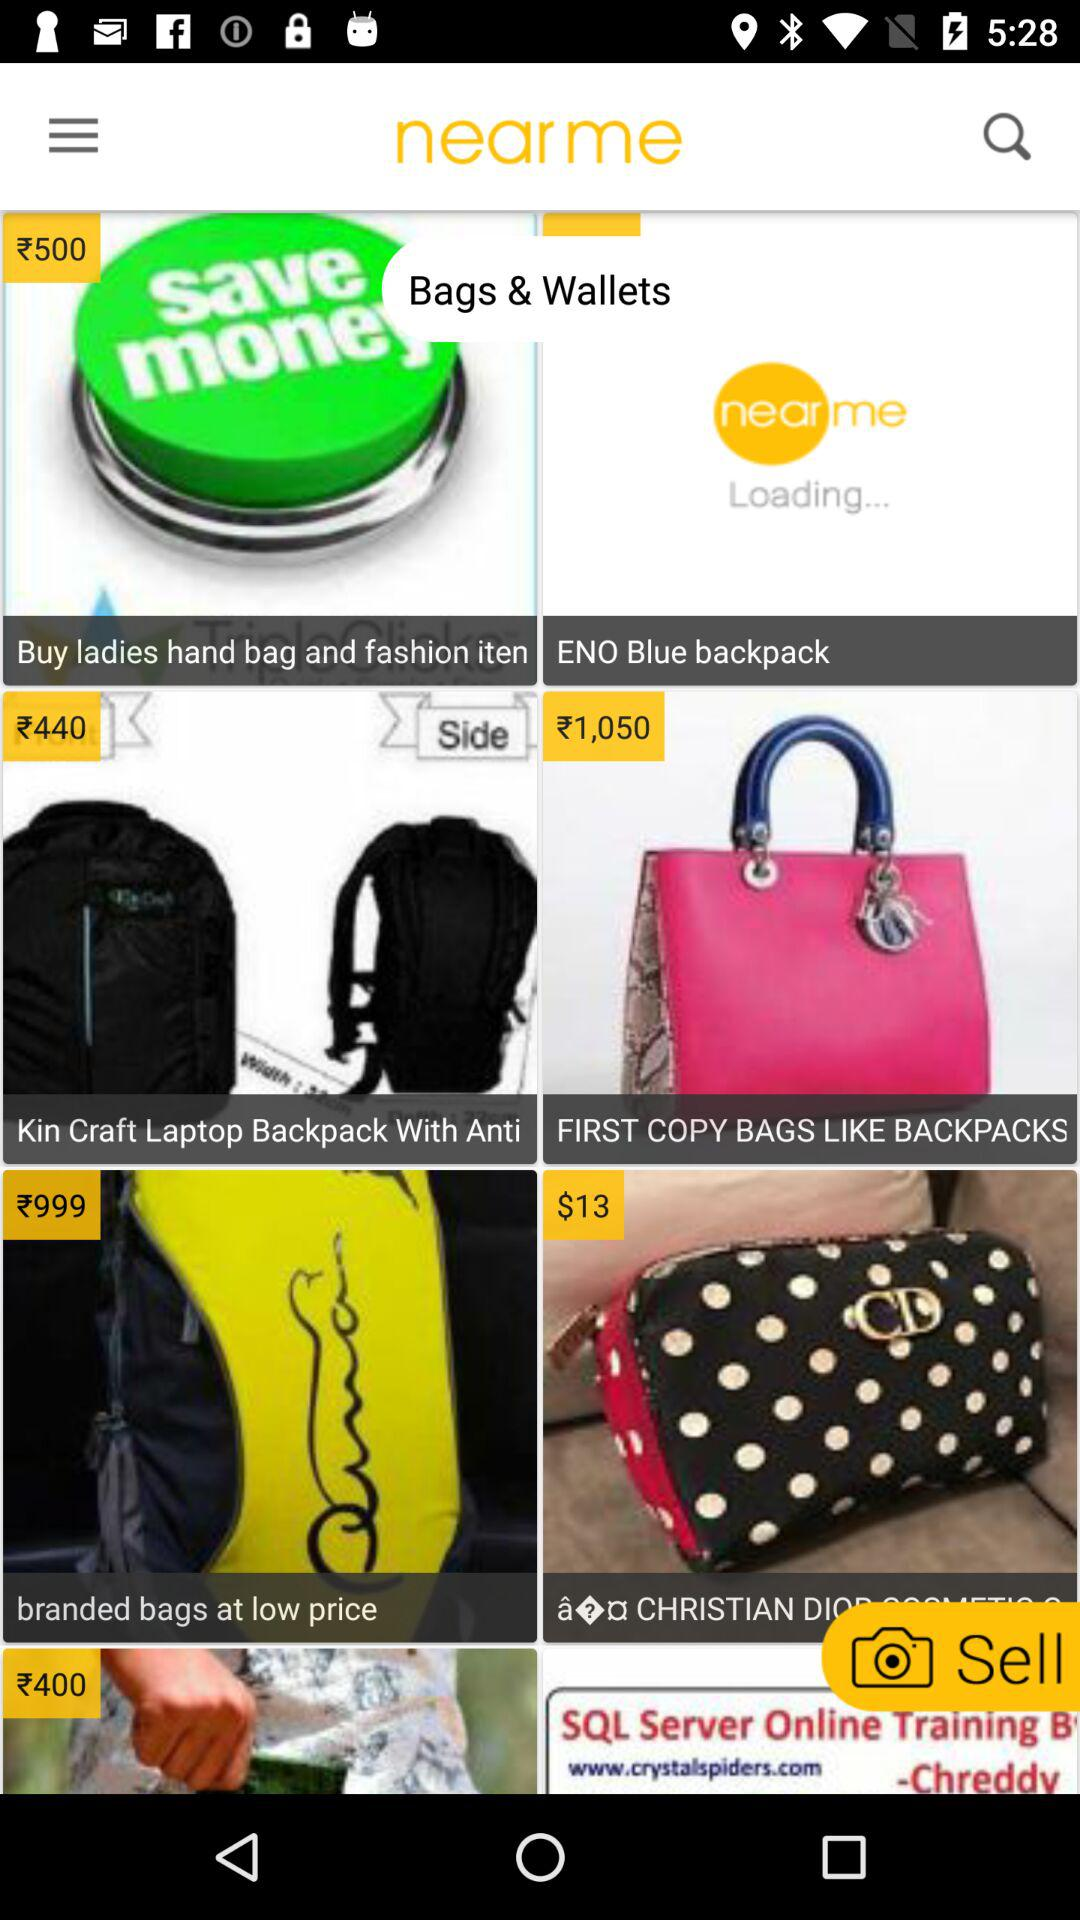Which item costs Rs 440? The item that costs Rs 440 is the "Kin Craft Laptop Backpack With Anti". 